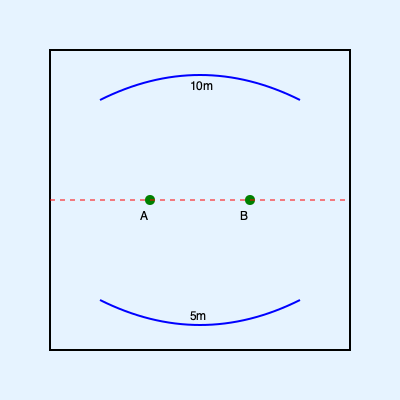Based on the lake map shown, which location (A or B) would likely be the most productive fishing spot for catching bass during the summer months? To determine the most productive fishing spot for bass during summer months, we need to consider several factors:

1. Depth contours: The map shows two depth contours, one at 10m and another at 5m. Bass often prefer areas with depth variations.

2. Vegetation markers: Both locations A and B are marked with green circles, indicating the presence of vegetation or structure.

3. Drop-off zones: The area between the 10m and 5m contour lines represents a drop-off zone, which bass frequently use.

4. Summer behavior: During summer, bass often seek cooler, deeper waters during the day and move to shallower areas to feed.

5. Location specifics:
   - Location A is situated closer to the drop-off zone between the 10m and 5m contours.
   - Location B is in a relatively uniform depth area.

6. Feeding patterns: Bass often ambush prey near drop-offs and use vegetation for cover.

Considering these factors, Location A is likely to be more productive because:
- It's closer to the drop-off zone, providing access to both deep and shallow water.
- It offers vegetation for cover and ambush opportunities.
- It allows bass to move between deeper, cooler water and shallower feeding areas more easily.

Therefore, Location A would likely be the most productive fishing spot for catching bass during summer months.
Answer: Location A 